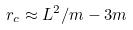<formula> <loc_0><loc_0><loc_500><loc_500>r _ { c } \approx L ^ { 2 } / m - 3 m</formula> 